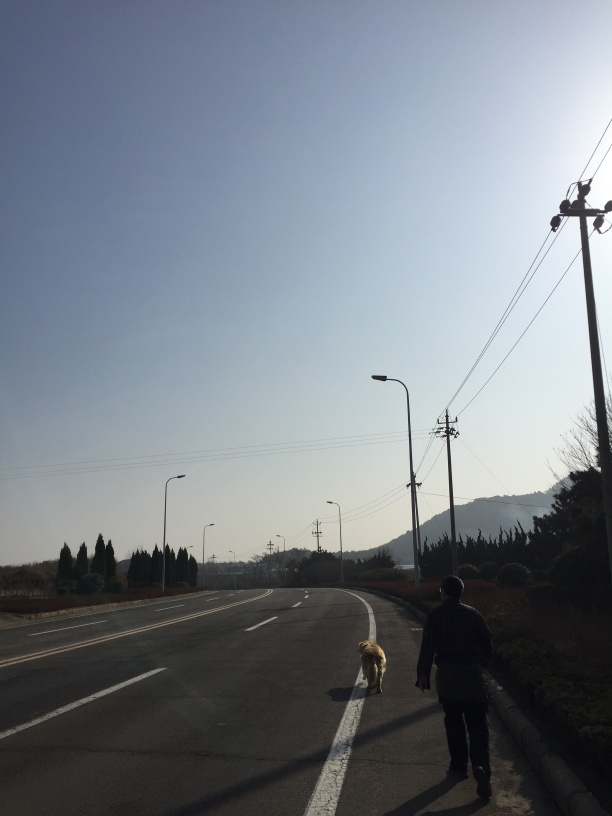What time of day does this image appear to have been taken? The long shadows and the warm color tone in the sky suggest that this image was likely taken in the late afternoon. 